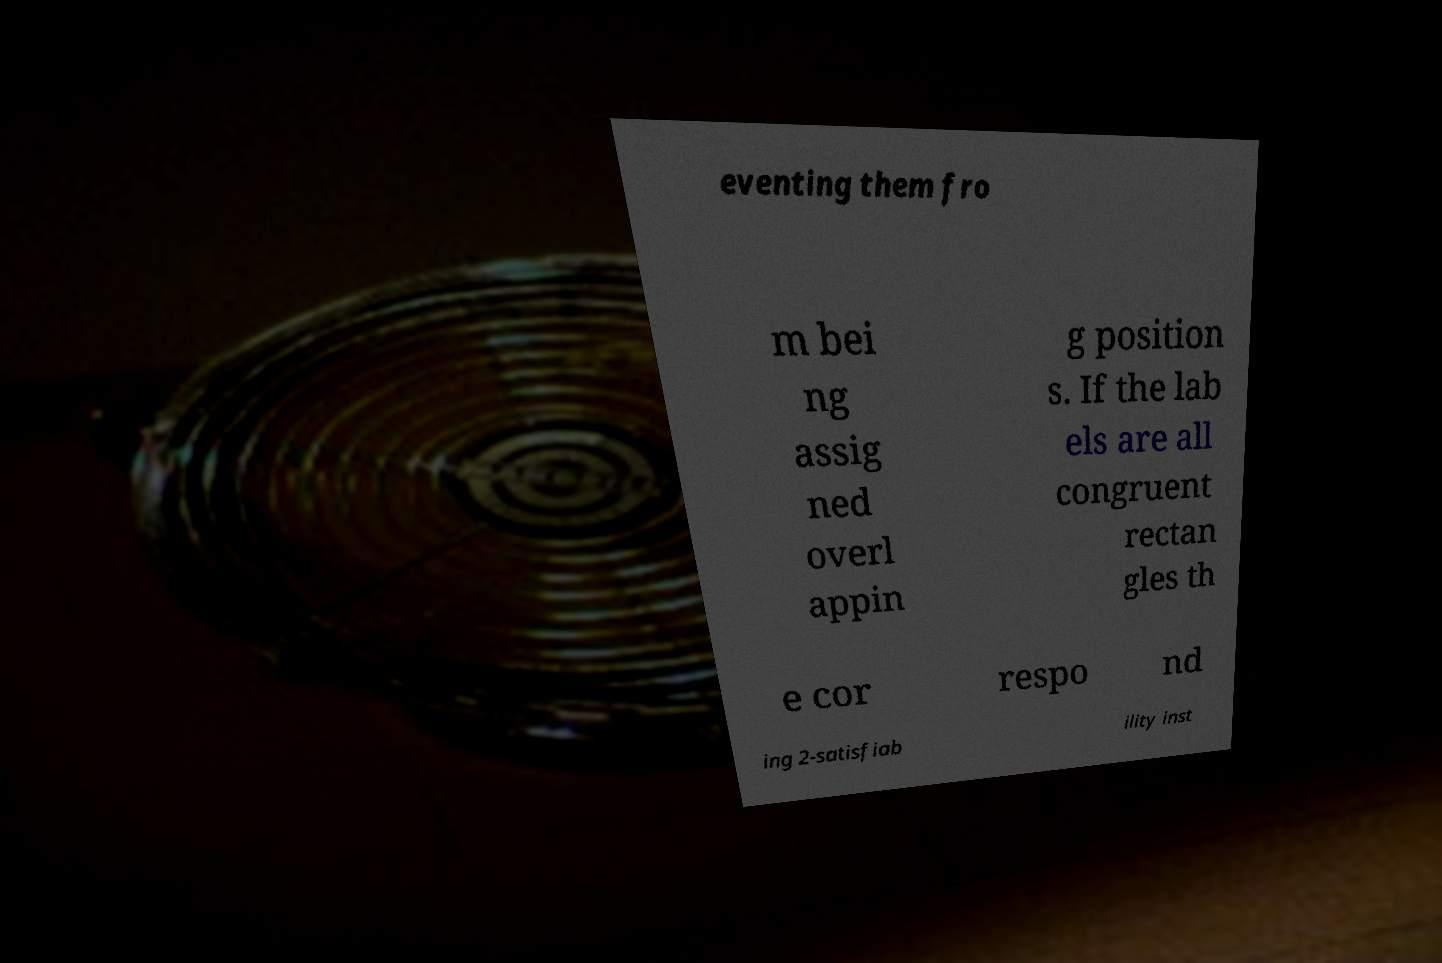Could you assist in decoding the text presented in this image and type it out clearly? eventing them fro m bei ng assig ned overl appin g position s. If the lab els are all congruent rectan gles th e cor respo nd ing 2-satisfiab ility inst 